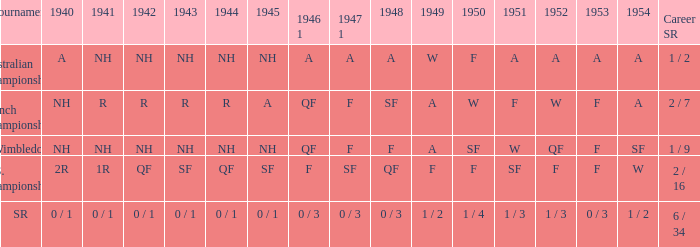In 1944, what were the results for the u.s. championships? QF. 